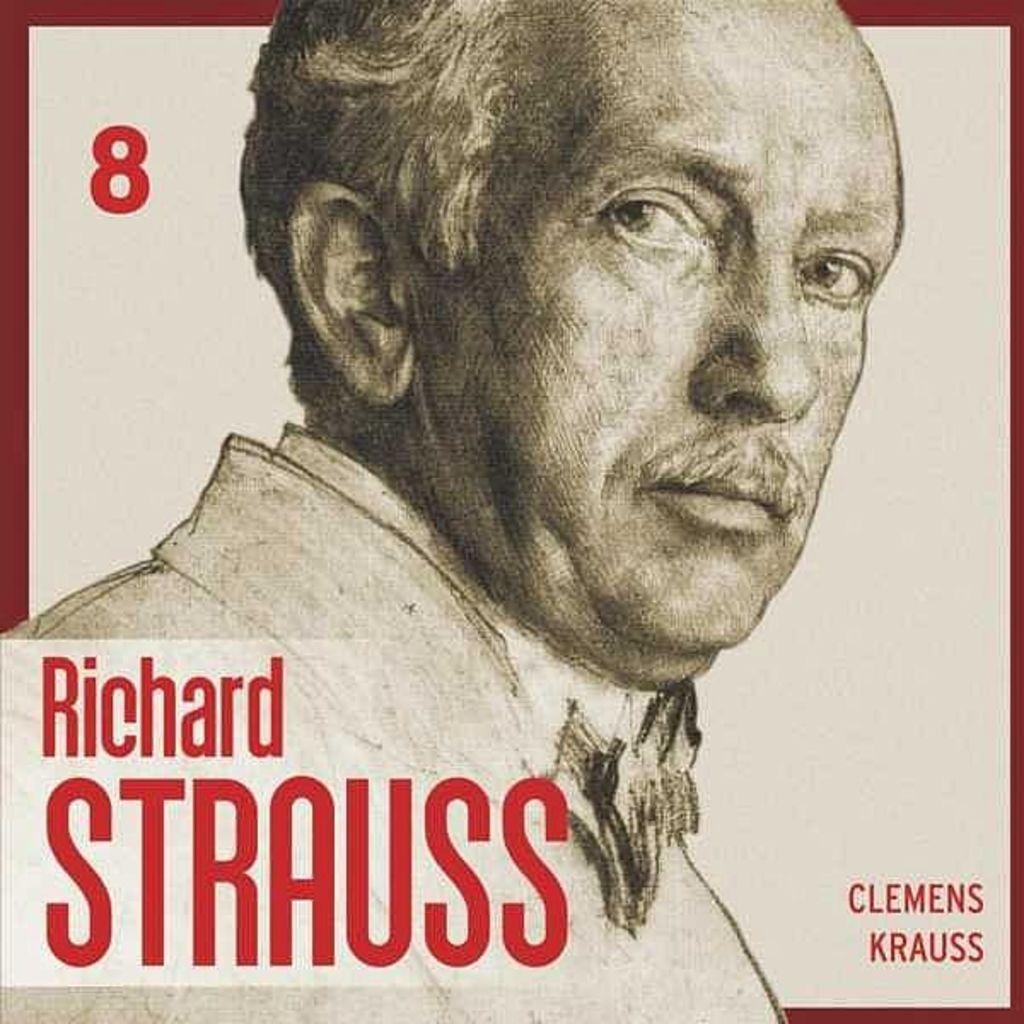Please provide a concise description of this image. In this image I can see a person, text and white color background. This image looks like a photo frame. 